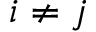Convert formula to latex. <formula><loc_0><loc_0><loc_500><loc_500>i \neq j</formula> 